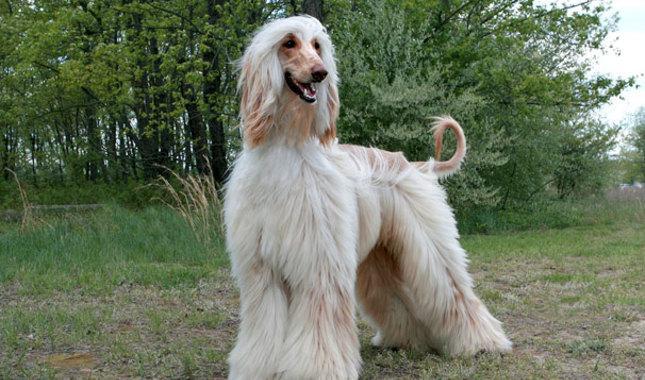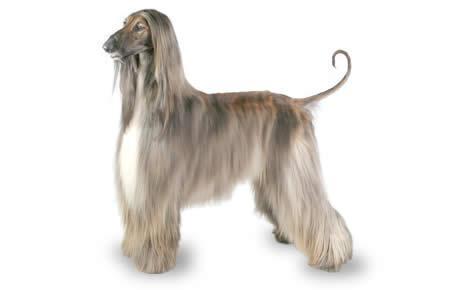The first image is the image on the left, the second image is the image on the right. For the images displayed, is the sentence "Only the left image shows a dog on a grassy area." factually correct? Answer yes or no. Yes. 